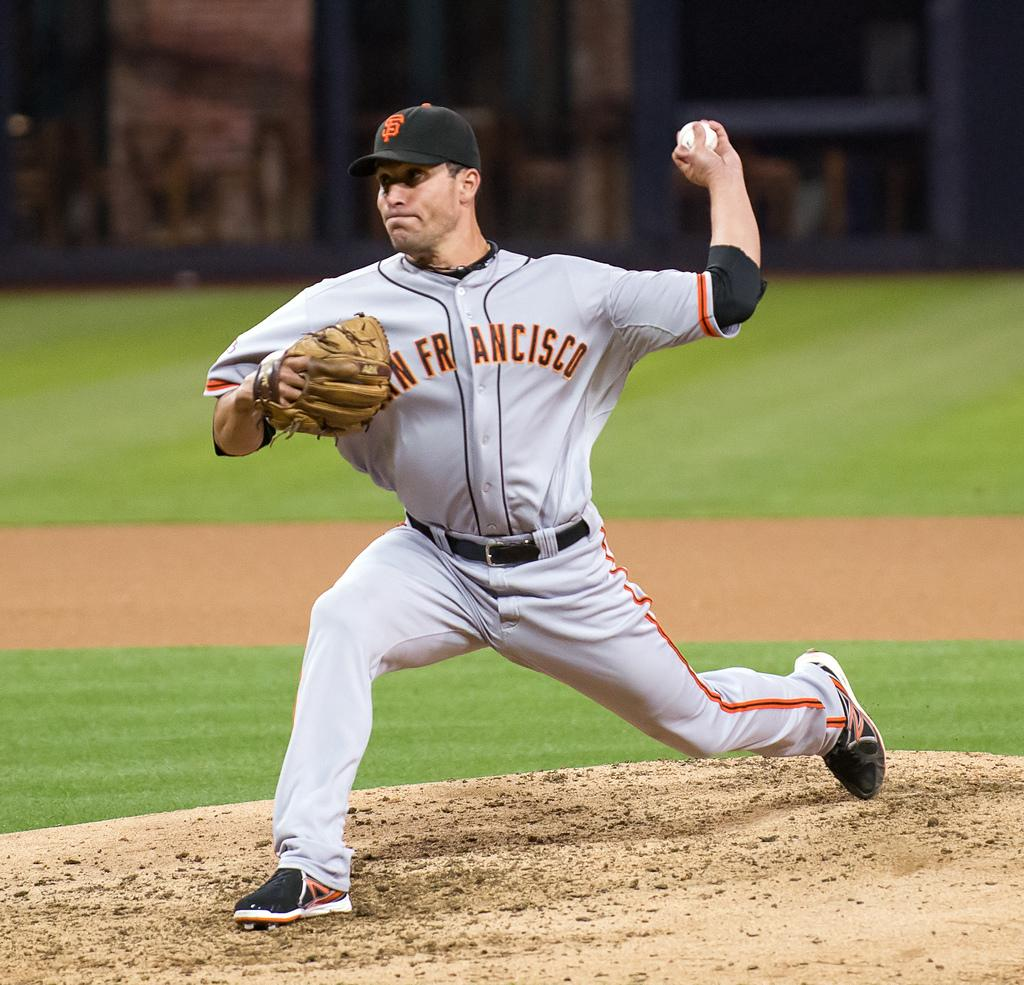Provide a one-sentence caption for the provided image. a man that is wearing a San Francisco jersey and playing baseball. 